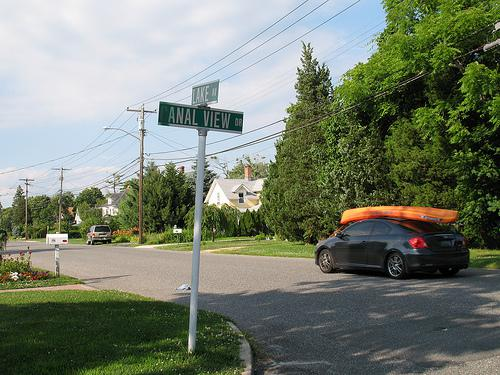Question: where are shadows?
Choices:
A. On the ground.
B. On the building.
C. On the street.
D. On the car.
Answer with the letter. Answer: A Question: where are clouds?
Choices:
A. Above our heads.
B. In the sky.
C. Above the trees.
D. Above the mountains.
Answer with the letter. Answer: B Question: where was the photo taken?
Choices:
A. The beach.
B. Near signs.
C. The car.
D. At work.
Answer with the letter. Answer: B Question: how many street signs are in the photo?
Choices:
A. Four.
B. Three.
C. Two.
D. None.
Answer with the letter. Answer: C Question: when was the picture taken?
Choices:
A. During the day.
B. During the night.
C. During the morning.
D. During the evening.
Answer with the letter. Answer: A Question: what is green?
Choices:
A. Broccoli.
B. Asparagus.
C. Trees.
D. Peas.
Answer with the letter. Answer: C Question: what is black?
Choices:
A. A bus.
B. A plane.
C. A bike.
D. A car.
Answer with the letter. Answer: D 